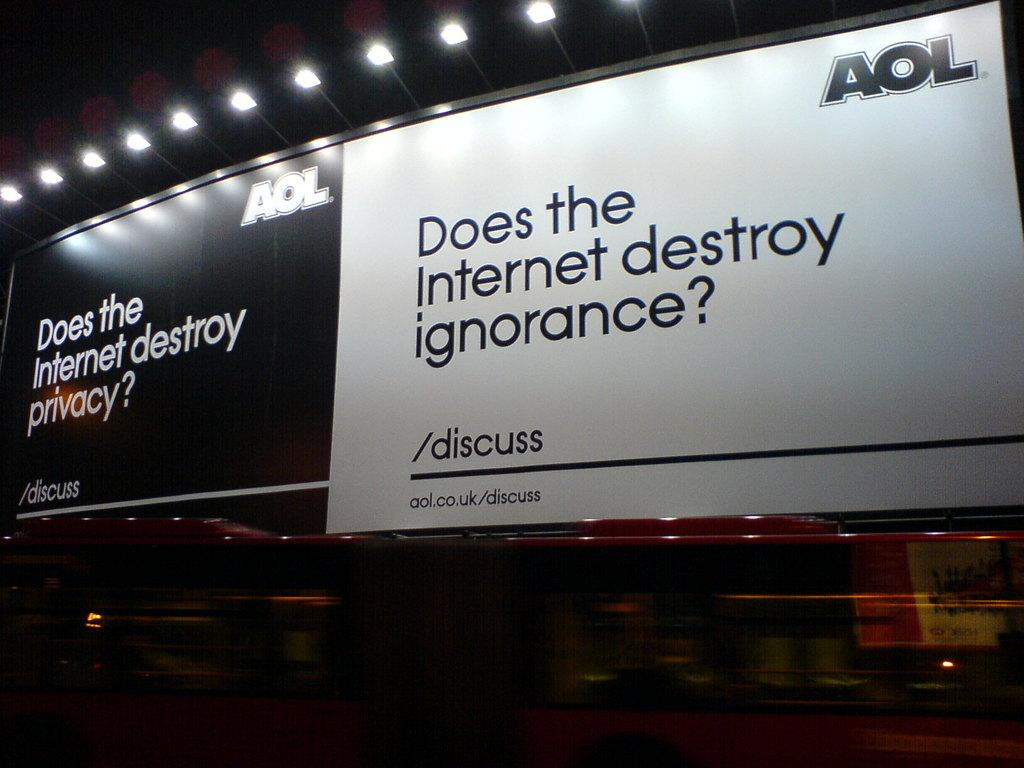<image>
Provide a brief description of the given image. A pair of banners that are advertisements for AOL talking about privacy and ignorance. 